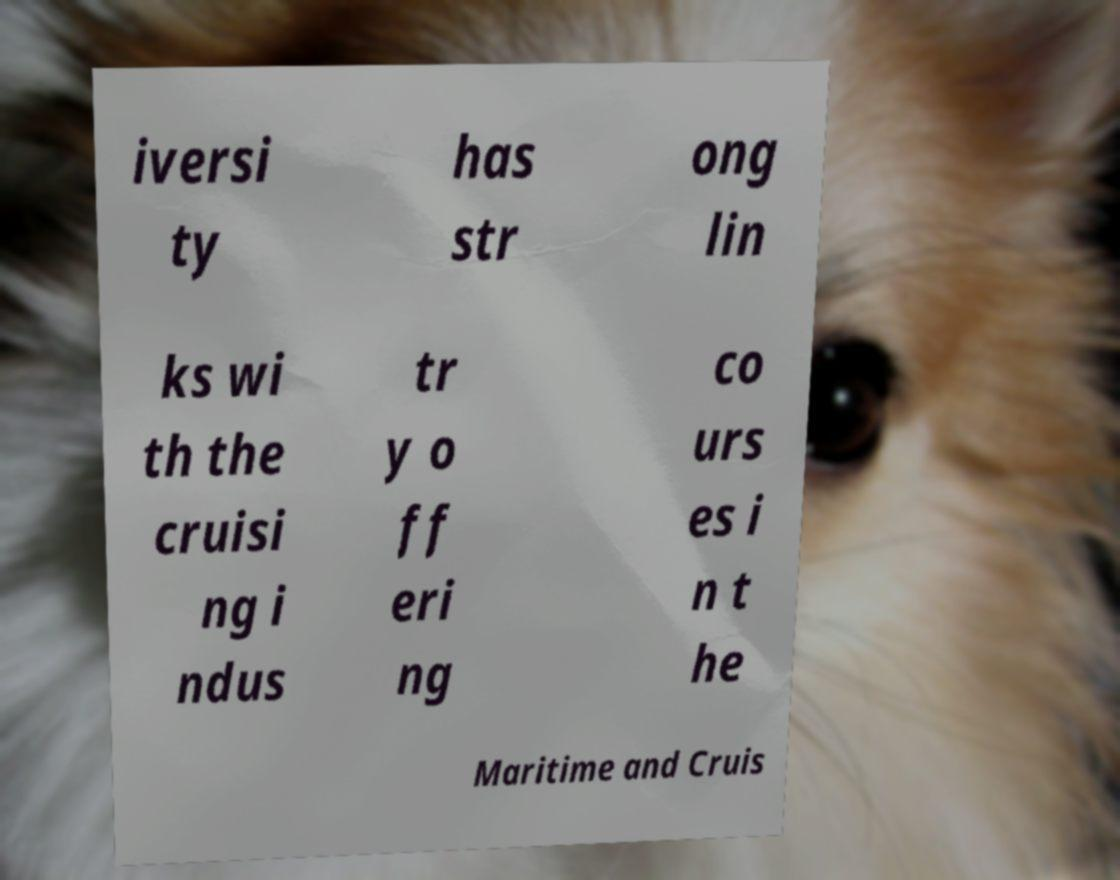I need the written content from this picture converted into text. Can you do that? iversi ty has str ong lin ks wi th the cruisi ng i ndus tr y o ff eri ng co urs es i n t he Maritime and Cruis 